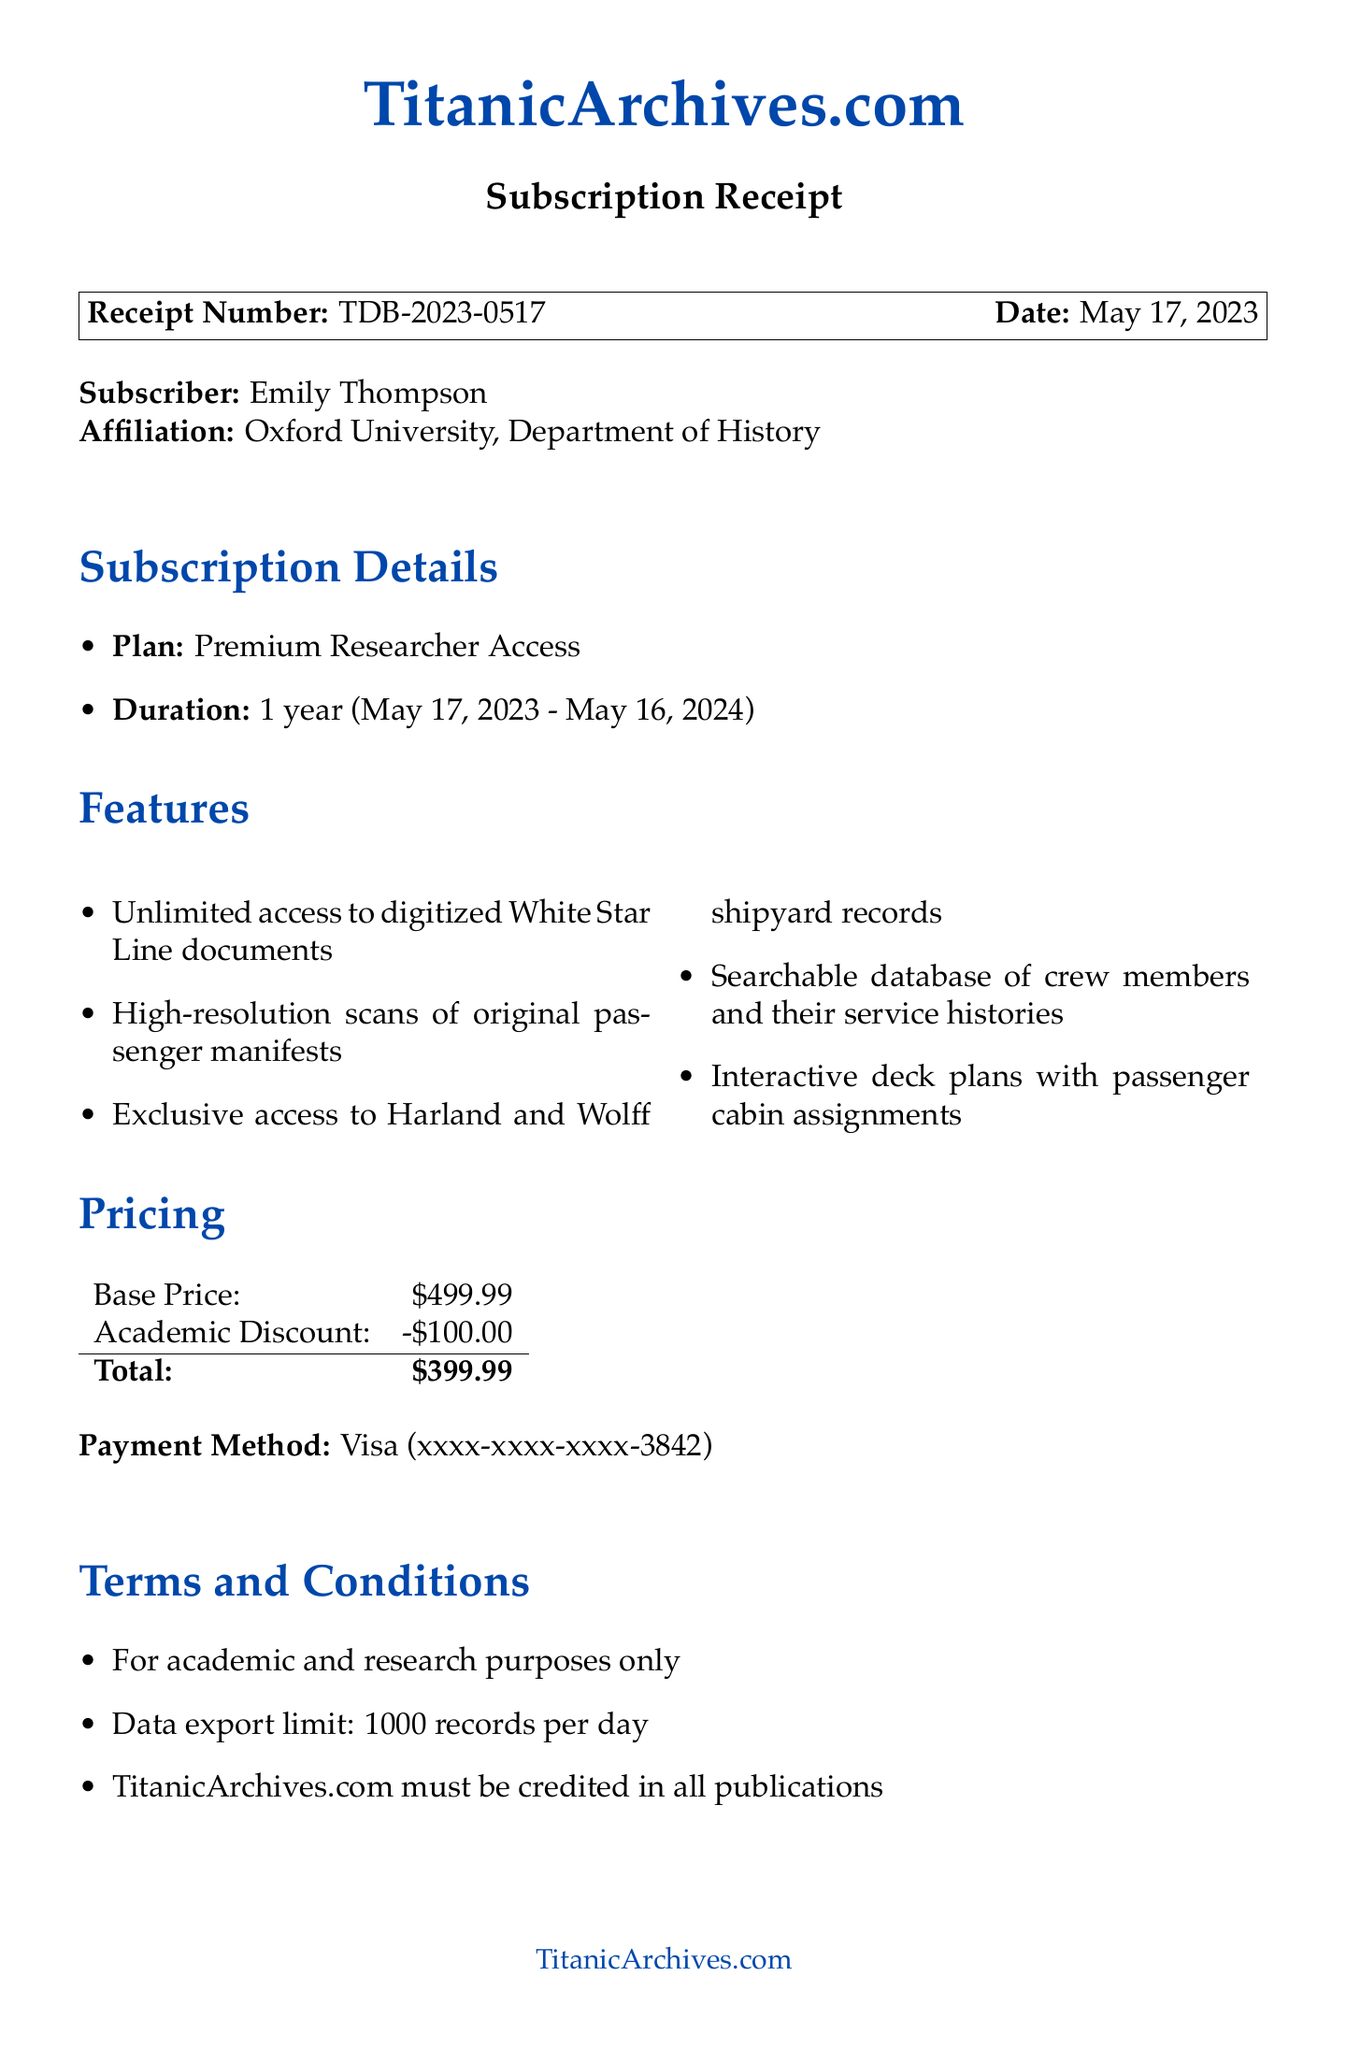What is the receipt number? The receipt number is a unique identifier provided in the document, which is TDB-2023-0517.
Answer: TDB-2023-0517 Who is the subscriber? The subscriber's name is provided in the document, which is Emily Thompson.
Answer: Emily Thompson What is the total price of the subscription? The total price is explicitly stated in the pricing section of the document, which is after applying the discount.
Answer: $399.99 What is the duration of the subscription? The duration is indicated directly in the subscription details, stating it lasts for one year.
Answer: 1 year What features are included in the subscription? Various features are listed in the document, indicating the access granted by the subscription.
Answer: Unlimited access to digitized White Star Line documents, High-resolution scans of original passenger manifests, Exclusive access to Harland and Wolff shipyard records, Searchable database of crew members and their service histories, Interactive deck plans with passenger cabin assignments When does the subscription start? The start date is provided in the subscription details ensuring clarity on when access begins.
Answer: May 17, 2023 What is the academic discount amount? The discount is mentioned in the pricing section of the document, specifically the amount deducted from the base price.
Answer: -$100.00 What email address is for customer support? The customer support email is listed in the contact information section of the document for assistance.
Answer: support@titanicarchives.com What payment method was used? The payment method indicates the type of card used for the transaction, which is detailed in the document.
Answer: Visa 